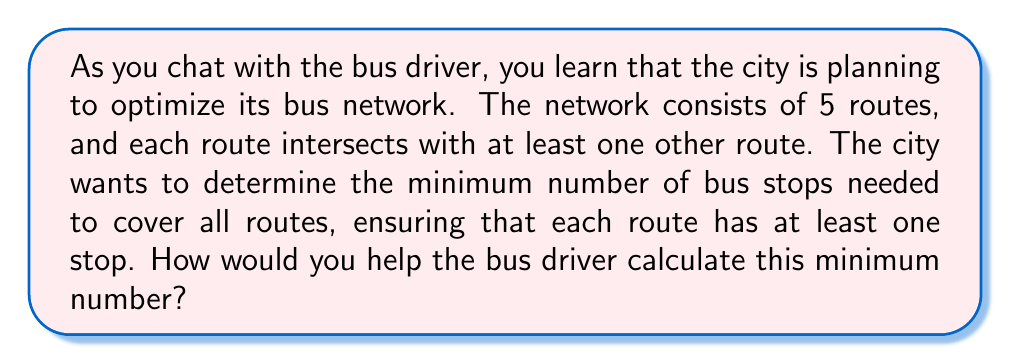Give your solution to this math problem. To solve this problem, we can use the concept of a vertex cover in graph theory. Here's how we can approach it:

1) First, we represent the bus network as a graph:
   - Each route is a vertex
   - An edge between two vertices exists if the corresponding routes intersect

2) Given the information that each route intersects with at least one other route, we know that the graph is connected and has at least 4 edges (to connect all 5 vertices).

3) The minimum number of stops needed is equivalent to finding the minimum vertex cover of this graph. A vertex cover is a set of vertices such that each edge of the graph is incident to at least one vertex of the set.

4) For a connected graph with 5 vertices, the minimum vertex cover can be at most 4 vertices (in the case of a star graph).

5) However, since we're told that each route intersects with at least one other route, we know it's not a star graph. The graph must have more connections.

6) In a graph with 5 vertices, the minimum vertex cover is usually 3, unless it's a complete graph (where every vertex is connected to every other vertex).

7) Even in a complete graph with 5 vertices, a vertex cover of 4 vertices is sufficient.

Therefore, the minimum number of stops needed to cover all routes is 3 or 4, depending on the exact configuration of route intersections.

Without more specific information about the route intersections, we can conclude that at most 4 stops are needed, and this will cover all possible configurations of the 5 routes.
Answer: At most 4 stops are needed to cover all 5 routes in the bus network. 